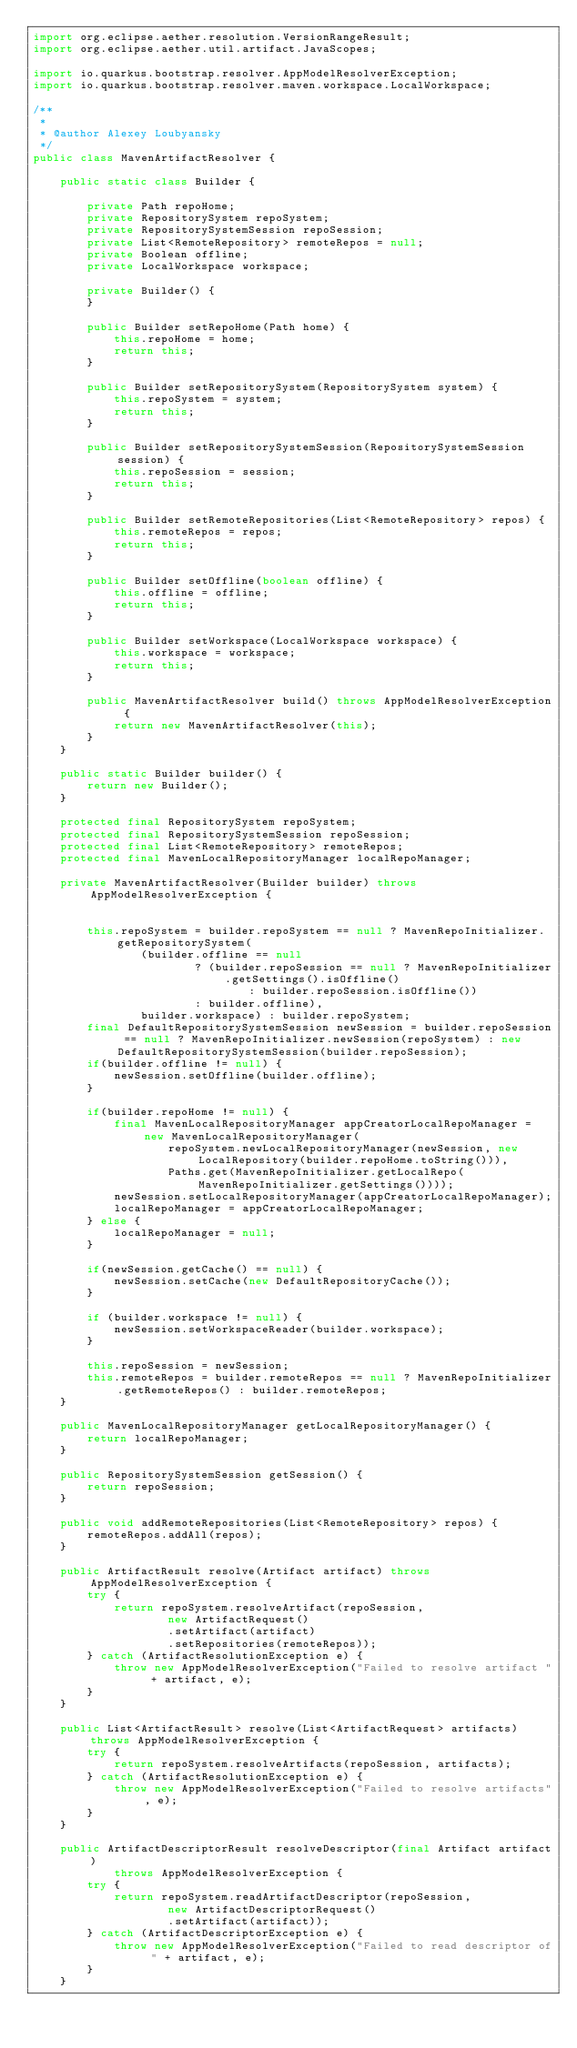Convert code to text. <code><loc_0><loc_0><loc_500><loc_500><_Java_>import org.eclipse.aether.resolution.VersionRangeResult;
import org.eclipse.aether.util.artifact.JavaScopes;

import io.quarkus.bootstrap.resolver.AppModelResolverException;
import io.quarkus.bootstrap.resolver.maven.workspace.LocalWorkspace;

/**
 *
 * @author Alexey Loubyansky
 */
public class MavenArtifactResolver {

    public static class Builder {

        private Path repoHome;
        private RepositorySystem repoSystem;
        private RepositorySystemSession repoSession;
        private List<RemoteRepository> remoteRepos = null;
        private Boolean offline;
        private LocalWorkspace workspace;

        private Builder() {
        }

        public Builder setRepoHome(Path home) {
            this.repoHome = home;
            return this;
        }

        public Builder setRepositorySystem(RepositorySystem system) {
            this.repoSystem = system;
            return this;
        }

        public Builder setRepositorySystemSession(RepositorySystemSession session) {
            this.repoSession = session;
            return this;
        }

        public Builder setRemoteRepositories(List<RemoteRepository> repos) {
            this.remoteRepos = repos;
            return this;
        }

        public Builder setOffline(boolean offline) {
            this.offline = offline;
            return this;
        }

        public Builder setWorkspace(LocalWorkspace workspace) {
            this.workspace = workspace;
            return this;
        }

        public MavenArtifactResolver build() throws AppModelResolverException {
            return new MavenArtifactResolver(this);
        }
    }

    public static Builder builder() {
        return new Builder();
    }

    protected final RepositorySystem repoSystem;
    protected final RepositorySystemSession repoSession;
    protected final List<RemoteRepository> remoteRepos;
    protected final MavenLocalRepositoryManager localRepoManager;

    private MavenArtifactResolver(Builder builder) throws AppModelResolverException {


        this.repoSystem = builder.repoSystem == null ? MavenRepoInitializer.getRepositorySystem(
                (builder.offline == null
                        ? (builder.repoSession == null ? MavenRepoInitializer.getSettings().isOffline()
                                : builder.repoSession.isOffline())
                        : builder.offline),
                builder.workspace) : builder.repoSystem;
        final DefaultRepositorySystemSession newSession = builder.repoSession == null ? MavenRepoInitializer.newSession(repoSystem) : new DefaultRepositorySystemSession(builder.repoSession);
        if(builder.offline != null) {
            newSession.setOffline(builder.offline);
        }

        if(builder.repoHome != null) {
            final MavenLocalRepositoryManager appCreatorLocalRepoManager = new MavenLocalRepositoryManager(
                    repoSystem.newLocalRepositoryManager(newSession, new LocalRepository(builder.repoHome.toString())),
                    Paths.get(MavenRepoInitializer.getLocalRepo(MavenRepoInitializer.getSettings())));
            newSession.setLocalRepositoryManager(appCreatorLocalRepoManager);
            localRepoManager = appCreatorLocalRepoManager;
        } else {
            localRepoManager = null;
        }

        if(newSession.getCache() == null) {
            newSession.setCache(new DefaultRepositoryCache());
        }

        if (builder.workspace != null) {
            newSession.setWorkspaceReader(builder.workspace);
        }

        this.repoSession = newSession;
        this.remoteRepos = builder.remoteRepos == null ? MavenRepoInitializer.getRemoteRepos() : builder.remoteRepos;
    }

    public MavenLocalRepositoryManager getLocalRepositoryManager() {
        return localRepoManager;
    }

    public RepositorySystemSession getSession() {
        return repoSession;
    }

    public void addRemoteRepositories(List<RemoteRepository> repos) {
        remoteRepos.addAll(repos);
    }

    public ArtifactResult resolve(Artifact artifact) throws AppModelResolverException {
        try {
            return repoSystem.resolveArtifact(repoSession,
                    new ArtifactRequest()
                    .setArtifact(artifact)
                    .setRepositories(remoteRepos));
        } catch (ArtifactResolutionException e) {
            throw new AppModelResolverException("Failed to resolve artifact " + artifact, e);
        }
    }

    public List<ArtifactResult> resolve(List<ArtifactRequest> artifacts) throws AppModelResolverException {
        try {
            return repoSystem.resolveArtifacts(repoSession, artifacts);
        } catch (ArtifactResolutionException e) {
            throw new AppModelResolverException("Failed to resolve artifacts", e);
        }
    }

    public ArtifactDescriptorResult resolveDescriptor(final Artifact artifact)
            throws AppModelResolverException {
        try {
            return repoSystem.readArtifactDescriptor(repoSession,
                    new ArtifactDescriptorRequest()
                    .setArtifact(artifact));
        } catch (ArtifactDescriptorException e) {
            throw new AppModelResolverException("Failed to read descriptor of " + artifact, e);
        }
    }
</code> 